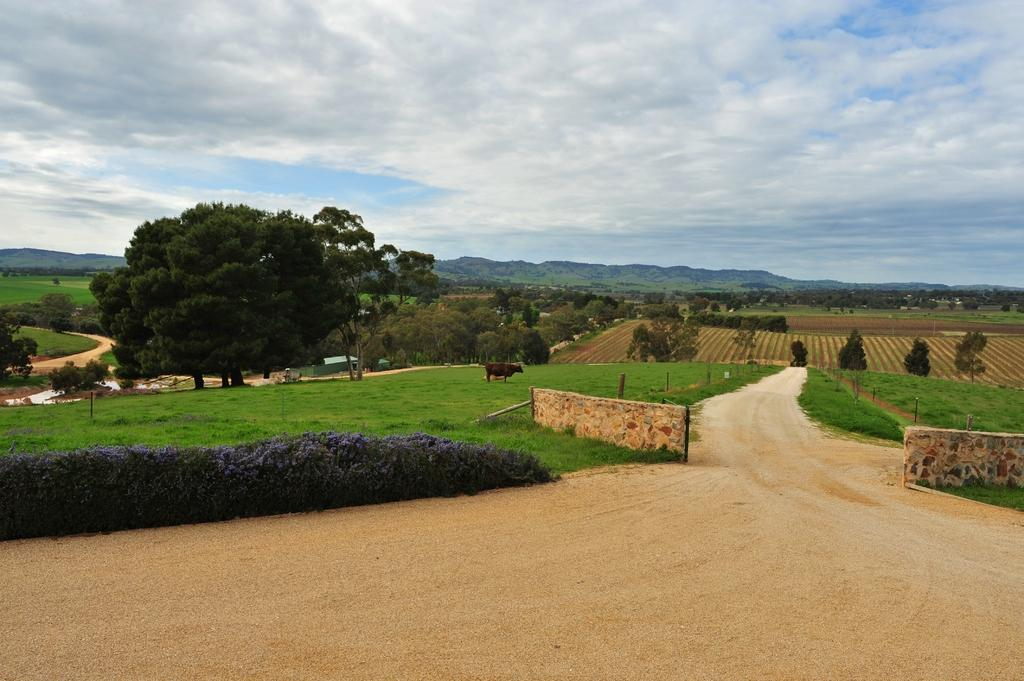What type of animal can be seen on the grass in the image? The image features an animal on the grass, but the specific type of animal is not mentioned in the facts. What type of structures can be seen in the image? Houses and walls are visible in the image. What type of vegetation is present in the image? Trees and grass are present in the image. What type of pathways can be seen in the image? Roads are visible in the image. Can you see any fairies flying around the animal on the grass in the image? There is no mention of fairies in the facts, so we cannot determine if they are present in the image. Is there any smoke coming from the houses in the image? The facts do not mention any smoke, so we cannot determine if it is present in the image. 